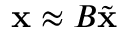<formula> <loc_0><loc_0><loc_500><loc_500>\begin{array} { r } { x \approx B \tilde { x } } \end{array}</formula> 